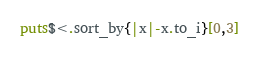<code> <loc_0><loc_0><loc_500><loc_500><_Ruby_>puts$<.sort_by{|x|-x.to_i}[0,3]</code> 